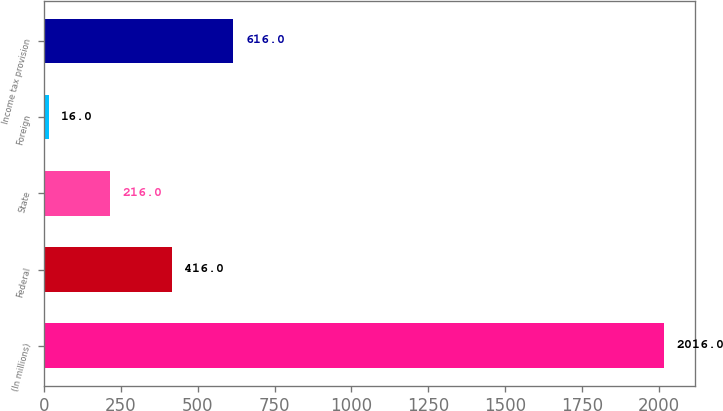Convert chart. <chart><loc_0><loc_0><loc_500><loc_500><bar_chart><fcel>(In millions)<fcel>Federal<fcel>State<fcel>Foreign<fcel>Income tax provision<nl><fcel>2016<fcel>416<fcel>216<fcel>16<fcel>616<nl></chart> 